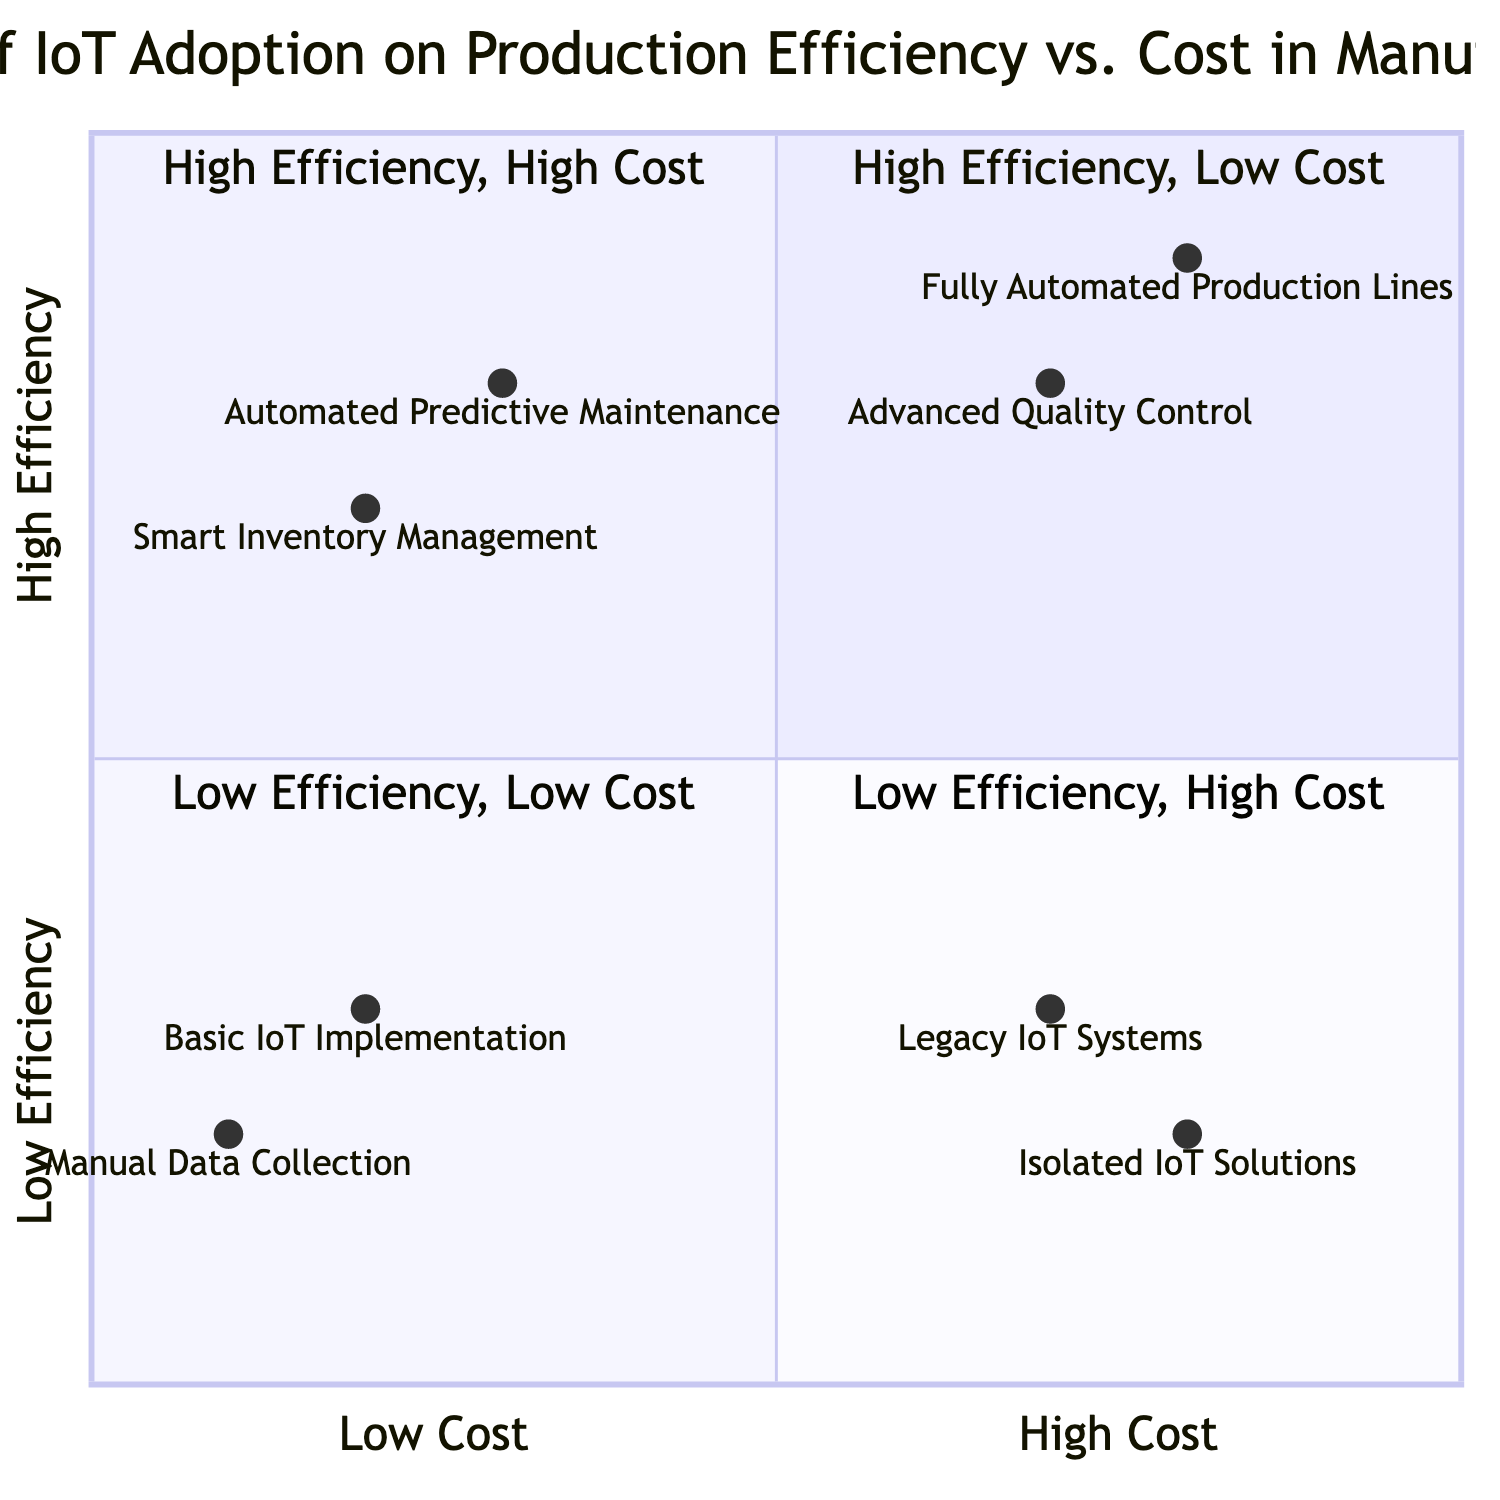What is the element with the highest production efficiency? The element with the highest production efficiency in the diagram is "Fully Automated Production Lines," which is located in the "High Efficiency, High Cost" quadrant. This is identified by its position and the given description.
Answer: Fully Automated Production Lines How many elements are in the "High Efficiency, Low Cost" quadrant? The "High Efficiency, Low Cost" quadrant contains two elements: "Automated Predictive Maintenance" and "Smart Inventory Management." Thus, there are a total of two elements.
Answer: 2 Which quadrant contains "Manual Data Collection"? "Manual Data Collection" is located in the "Low Efficiency, Low Cost" quadrant, as indicated by its position in the diagram.
Answer: Low Efficiency, Low Cost What is the cost level for "Smart Inventory Management"? "Smart Inventory Management" is represented at the position [0.2, 0.7] in the diagram, where the x-coordinate (cost) is 0.2, indicating a low cost level.
Answer: Low Cost Which element has higher efficiency: "Legacy IoT Systems" or "Isolated IoT Solutions"? Comparing the efficiency levels identified by their y-coordinates, "Legacy IoT Systems" has an efficiency of 0.3, and "Isolated IoT Solutions" has an efficiency of 0.2. Thus, "Legacy IoT Systems" has higher efficiency.
Answer: Legacy IoT Systems What is the description of the element in the "High Efficiency, High Cost" quadrant with real-time quality monitoring? The element with real-time quality monitoring in the "High Efficiency, High Cost" quadrant is "Advanced Quality Control," which is described as utilizing IoT and AI for real-time quality monitoring, reducing defects but with high implementation costs.
Answer: Advanced Quality Control How many quadrants are there in the chart? The chart is divided into four distinct quadrants, each representing a combination of production efficiency and cost. The quadrants are named according to their efficiency and cost characteristics.
Answer: 4 Which quadrant contains the element with the name "Basic IoT Implementation"? "Basic IoT Implementation" is located in the "Low Efficiency, Low Cost" quadrant, as indicated by its coordinates and the quadrant classification.
Answer: Low Efficiency, Low Cost 